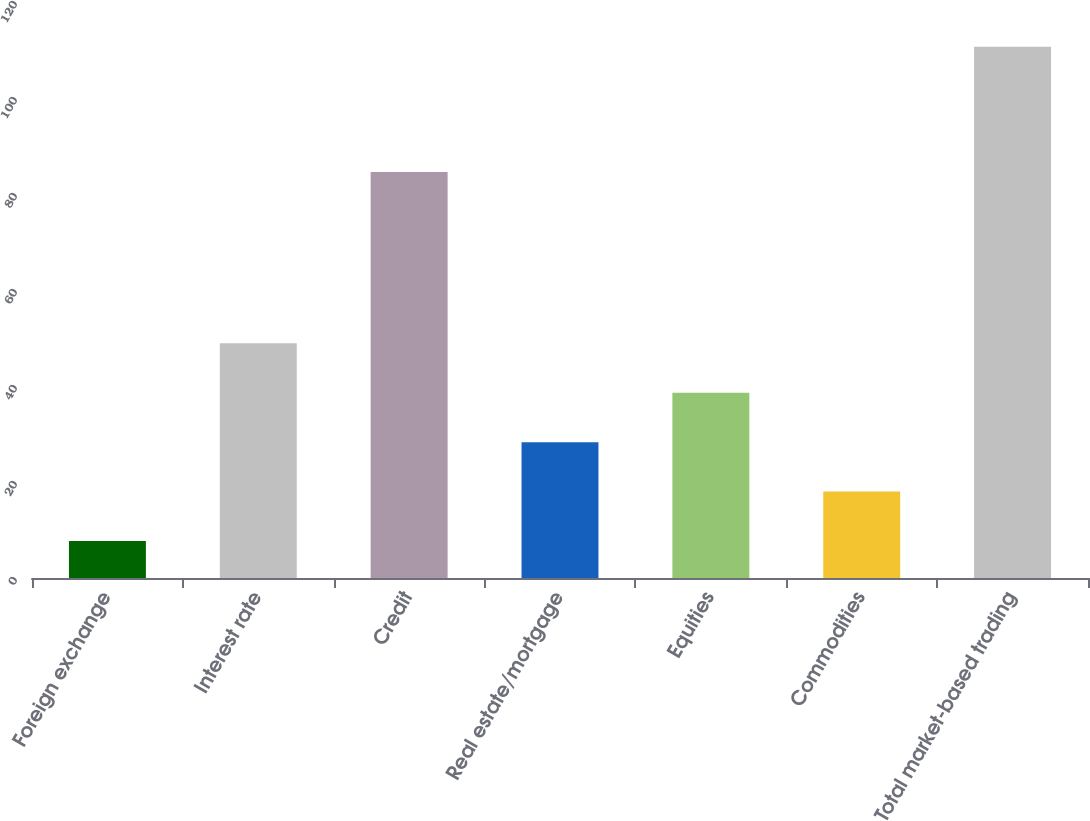Convert chart. <chart><loc_0><loc_0><loc_500><loc_500><bar_chart><fcel>Foreign exchange<fcel>Interest rate<fcel>Credit<fcel>Real estate/mortgage<fcel>Equities<fcel>Commodities<fcel>Total market-based trading<nl><fcel>7.7<fcel>48.9<fcel>84.6<fcel>28.3<fcel>38.6<fcel>18<fcel>110.7<nl></chart> 